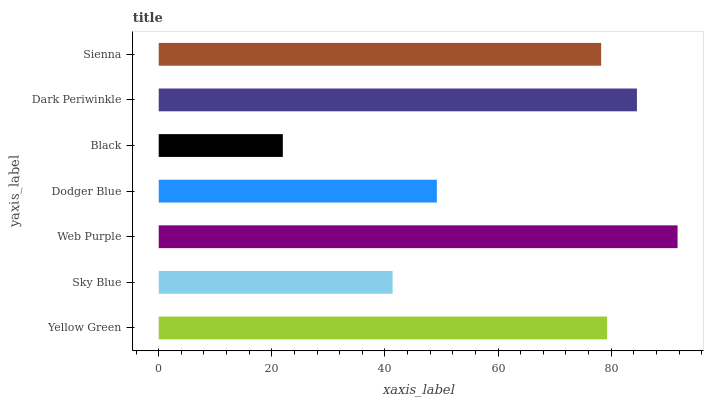Is Black the minimum?
Answer yes or no. Yes. Is Web Purple the maximum?
Answer yes or no. Yes. Is Sky Blue the minimum?
Answer yes or no. No. Is Sky Blue the maximum?
Answer yes or no. No. Is Yellow Green greater than Sky Blue?
Answer yes or no. Yes. Is Sky Blue less than Yellow Green?
Answer yes or no. Yes. Is Sky Blue greater than Yellow Green?
Answer yes or no. No. Is Yellow Green less than Sky Blue?
Answer yes or no. No. Is Sienna the high median?
Answer yes or no. Yes. Is Sienna the low median?
Answer yes or no. Yes. Is Dark Periwinkle the high median?
Answer yes or no. No. Is Yellow Green the low median?
Answer yes or no. No. 